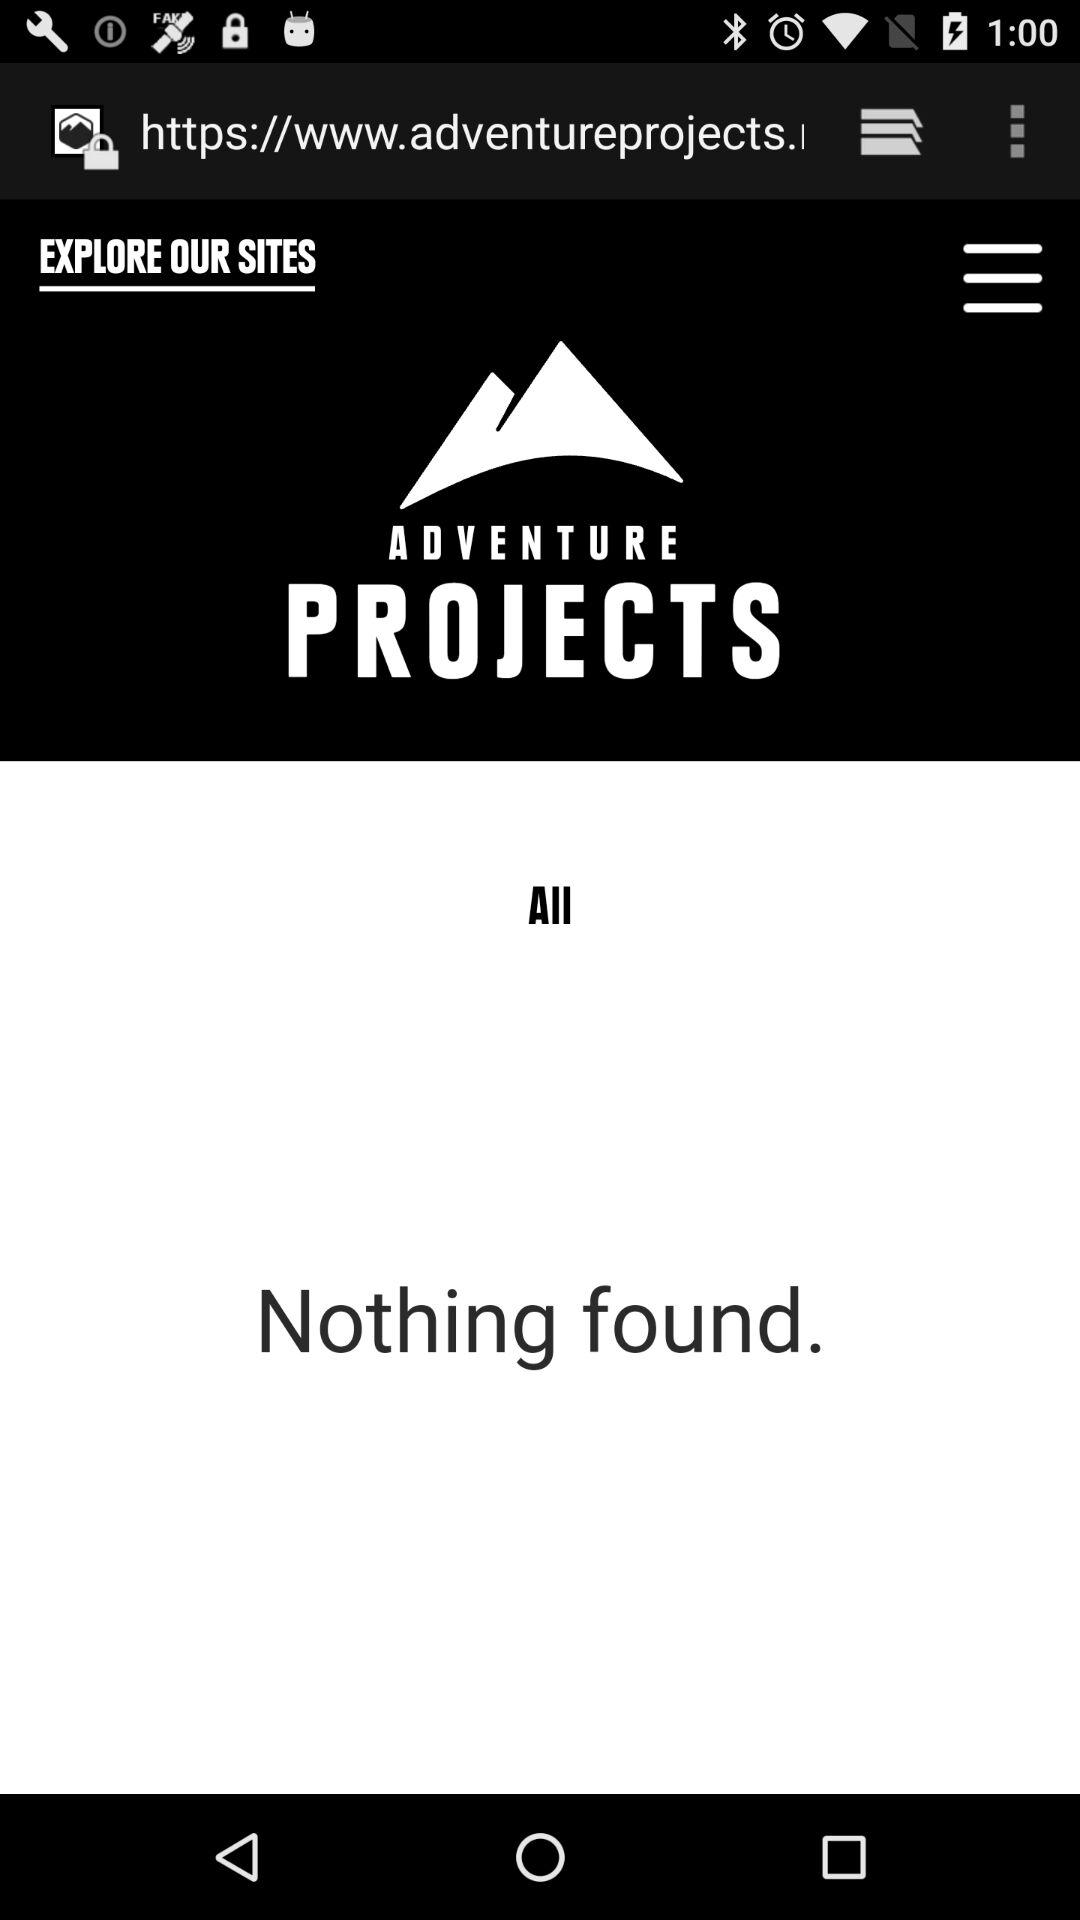What is the name of application?
When the provided information is insufficient, respond with <no answer>. <no answer> 